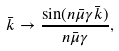<formula> <loc_0><loc_0><loc_500><loc_500>\bar { k } \rightarrow \frac { \sin ( n \bar { \mu } \gamma \bar { k } ) } { n \bar { \mu } \gamma } ,</formula> 